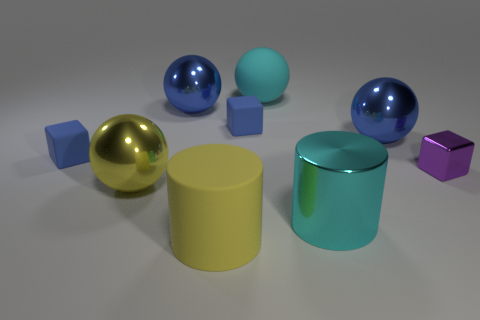Can you describe the material properties of the objects in the image? Certainly! The objects in the image seem to have differing material properties. The yellow and the two blue spheres have a reflective and glossy surface, which suggests a smooth, possibly metal or polished plastic finish. The yellow cylinder and the cyan cylinder with a metal appearance have a matte finish that scatters light uniformly, suggesting a more diffuse surface, possibly painted metal or a non-shiny plastic. The three smaller cubes appear to have a uniform color and matte finish as well, which could indicate a solid plastic or painted wood material. 